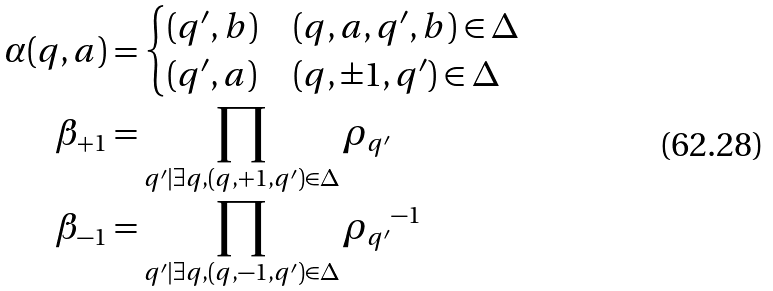Convert formula to latex. <formula><loc_0><loc_0><loc_500><loc_500>\alpha ( q , a ) & = \begin{cases} ( q ^ { \prime } , b ) & ( q , a , q ^ { \prime } , b ) \in \Delta \\ ( q ^ { \prime } , a ) & ( q , \pm 1 , q ^ { \prime } ) \in \Delta \end{cases} \\ \beta _ { + 1 } & = \prod _ { q ^ { \prime } | \exists q , ( q , + 1 , q ^ { \prime } ) \in \Delta } \rho _ { q ^ { \prime } } \\ \beta _ { - 1 } & = \prod _ { q ^ { \prime } | \exists q , ( q , - 1 , q ^ { \prime } ) \in \Delta } { \rho _ { q ^ { \prime } } } ^ { - 1 }</formula> 